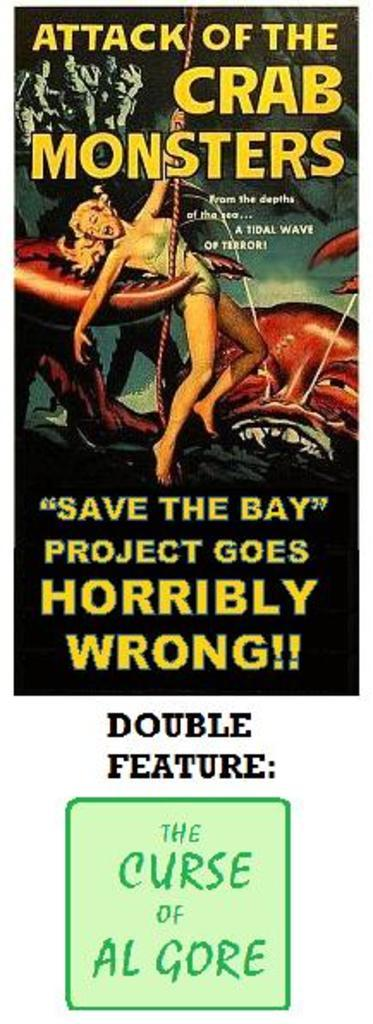<image>
Describe the image concisely. A poster advertising the movie Attack of The Crab Monsters. 